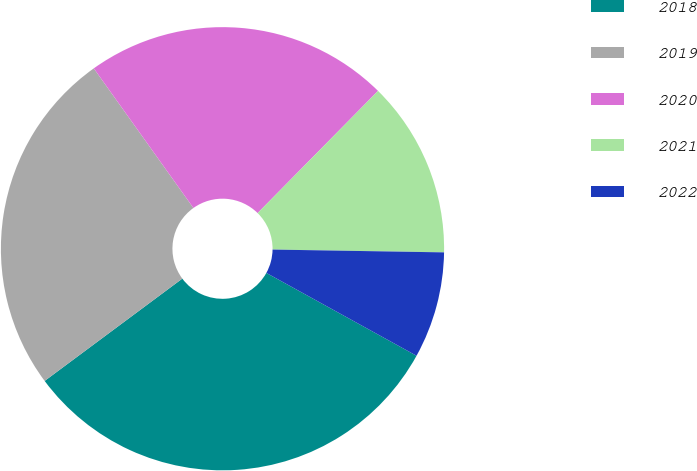Convert chart to OTSL. <chart><loc_0><loc_0><loc_500><loc_500><pie_chart><fcel>2018<fcel>2019<fcel>2020<fcel>2021<fcel>2022<nl><fcel>31.81%<fcel>25.31%<fcel>22.25%<fcel>12.88%<fcel>7.76%<nl></chart> 